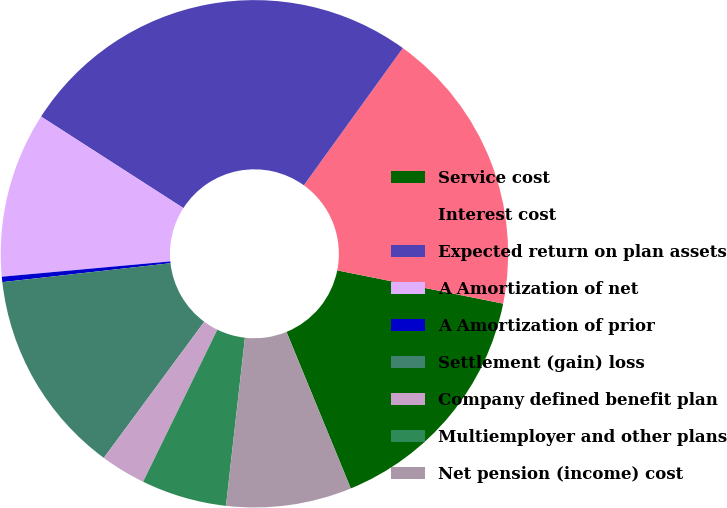Convert chart to OTSL. <chart><loc_0><loc_0><loc_500><loc_500><pie_chart><fcel>Service cost<fcel>Interest cost<fcel>Expected return on plan assets<fcel>A Amortization of net<fcel>A Amortization of prior<fcel>Settlement (gain) loss<fcel>Company defined benefit plan<fcel>Multiemployer and other plans<fcel>Net pension (income) cost<nl><fcel>15.65%<fcel>18.2%<fcel>25.85%<fcel>10.54%<fcel>0.34%<fcel>13.1%<fcel>2.89%<fcel>5.44%<fcel>7.99%<nl></chart> 